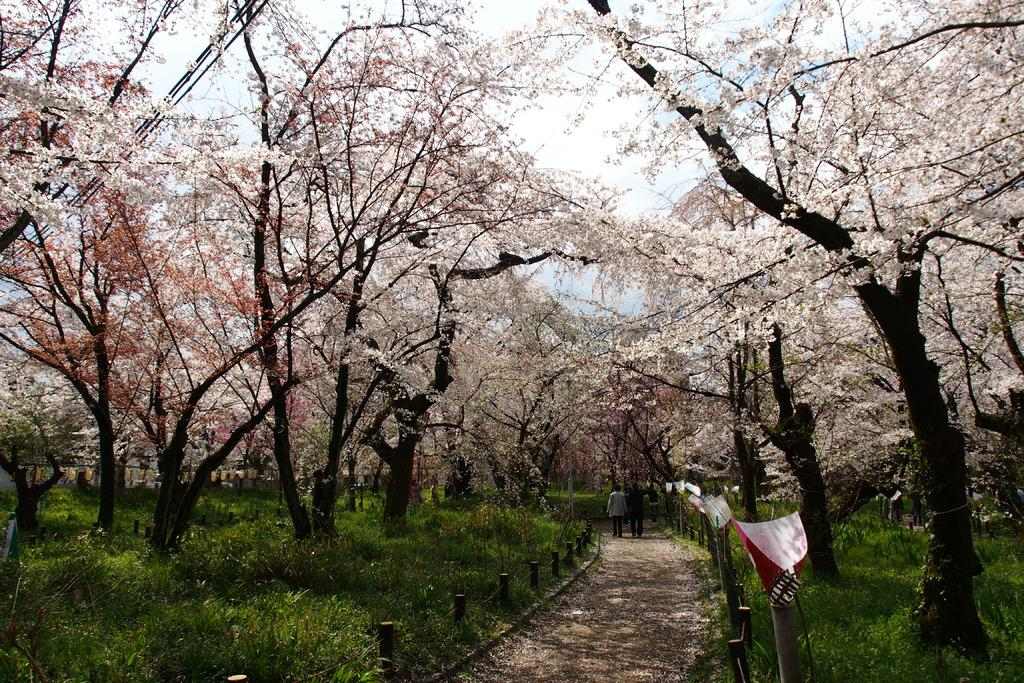What type of vegetation can be seen in the image? There are trees, plants, and grass in the image. What kind of path is present in the image? There is a walkway in the image. Who or what is present in the image? There are persons in the image. What is visible in the background of the image? The sky is visible in the image. What type of business is being conducted in the image? There is no indication of any business activity in the image; it primarily features natural elements and persons. What is the texture of the act in the image? There is no act present in the image, and therefore no texture can be determined. 